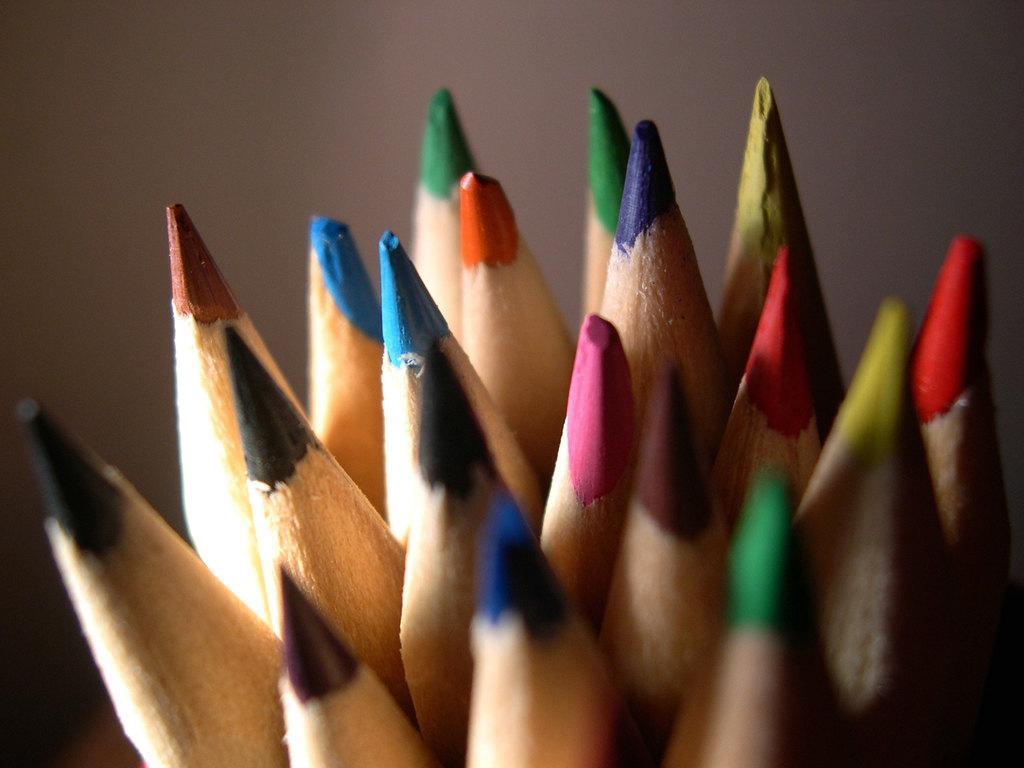How would you summarize this image in a sentence or two? These are the different color pencils that are shaped. 